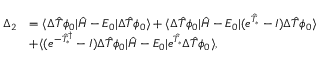Convert formula to latex. <formula><loc_0><loc_0><loc_500><loc_500>\begin{array} { r l } { \Delta _ { 2 } } & { = \langle \Delta \hat { T } \phi _ { 0 } | \hat { H } - E _ { 0 } | \Delta \hat { T } \phi _ { 0 } \rangle + \langle \Delta \hat { T } \phi _ { 0 } | \hat { H } - E _ { 0 } | ( e ^ { \hat { T } _ { * } } - I ) \Delta \hat { T } \phi _ { 0 } \rangle } \\ & { + \langle ( e ^ { - \hat { T } _ { * } ^ { \dagger } } - I ) \Delta \hat { T } \phi _ { 0 } | \hat { H } - E _ { 0 } | e ^ { \hat { T } _ { * } } \Delta \hat { T } \phi _ { 0 } \rangle , } \end{array}</formula> 